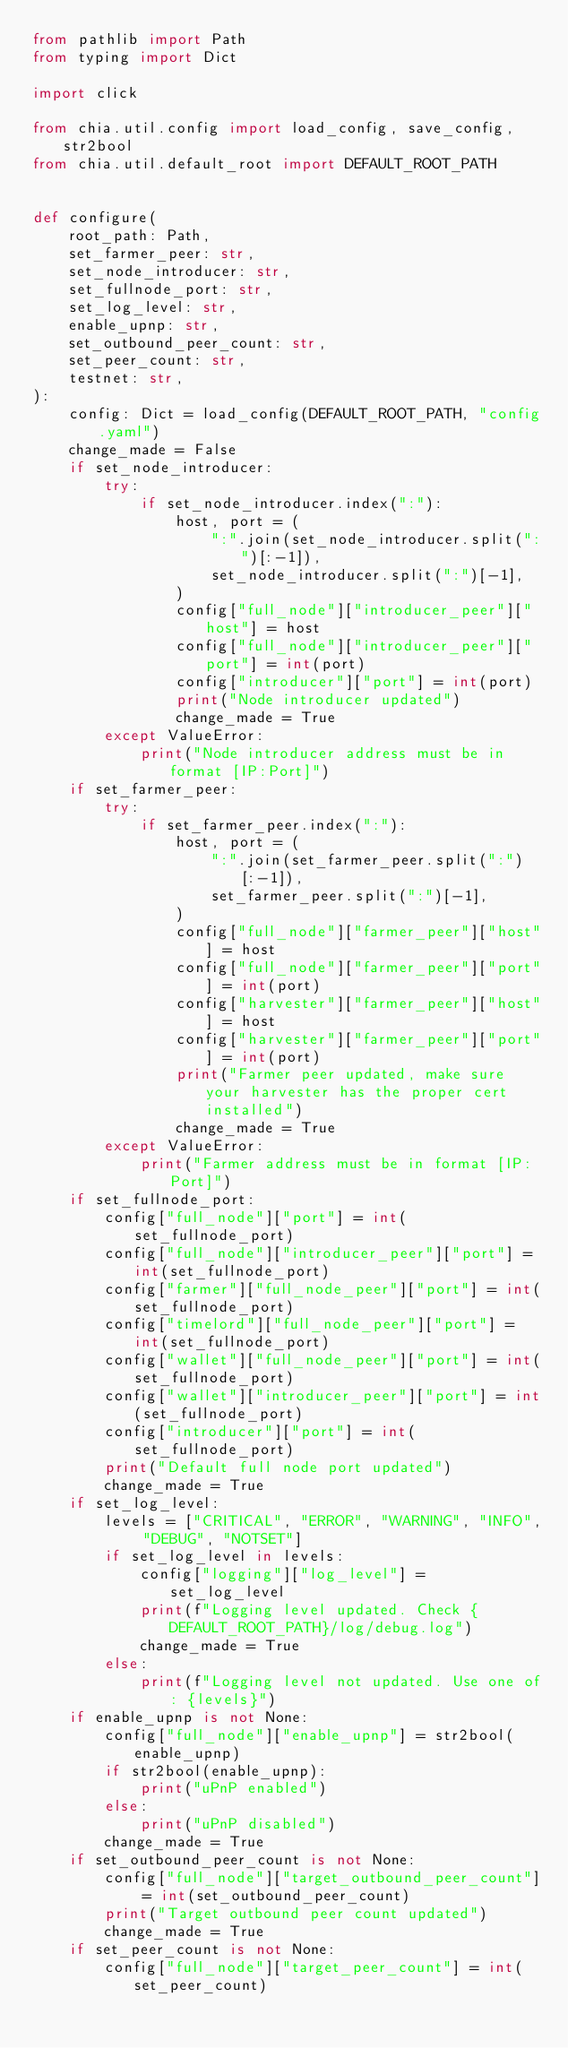<code> <loc_0><loc_0><loc_500><loc_500><_Python_>from pathlib import Path
from typing import Dict

import click

from chia.util.config import load_config, save_config, str2bool
from chia.util.default_root import DEFAULT_ROOT_PATH


def configure(
    root_path: Path,
    set_farmer_peer: str,
    set_node_introducer: str,
    set_fullnode_port: str,
    set_log_level: str,
    enable_upnp: str,
    set_outbound_peer_count: str,
    set_peer_count: str,
    testnet: str,
):
    config: Dict = load_config(DEFAULT_ROOT_PATH, "config.yaml")
    change_made = False
    if set_node_introducer:
        try:
            if set_node_introducer.index(":"):
                host, port = (
                    ":".join(set_node_introducer.split(":")[:-1]),
                    set_node_introducer.split(":")[-1],
                )
                config["full_node"]["introducer_peer"]["host"] = host
                config["full_node"]["introducer_peer"]["port"] = int(port)
                config["introducer"]["port"] = int(port)
                print("Node introducer updated")
                change_made = True
        except ValueError:
            print("Node introducer address must be in format [IP:Port]")
    if set_farmer_peer:
        try:
            if set_farmer_peer.index(":"):
                host, port = (
                    ":".join(set_farmer_peer.split(":")[:-1]),
                    set_farmer_peer.split(":")[-1],
                )
                config["full_node"]["farmer_peer"]["host"] = host
                config["full_node"]["farmer_peer"]["port"] = int(port)
                config["harvester"]["farmer_peer"]["host"] = host
                config["harvester"]["farmer_peer"]["port"] = int(port)
                print("Farmer peer updated, make sure your harvester has the proper cert installed")
                change_made = True
        except ValueError:
            print("Farmer address must be in format [IP:Port]")
    if set_fullnode_port:
        config["full_node"]["port"] = int(set_fullnode_port)
        config["full_node"]["introducer_peer"]["port"] = int(set_fullnode_port)
        config["farmer"]["full_node_peer"]["port"] = int(set_fullnode_port)
        config["timelord"]["full_node_peer"]["port"] = int(set_fullnode_port)
        config["wallet"]["full_node_peer"]["port"] = int(set_fullnode_port)
        config["wallet"]["introducer_peer"]["port"] = int(set_fullnode_port)
        config["introducer"]["port"] = int(set_fullnode_port)
        print("Default full node port updated")
        change_made = True
    if set_log_level:
        levels = ["CRITICAL", "ERROR", "WARNING", "INFO", "DEBUG", "NOTSET"]
        if set_log_level in levels:
            config["logging"]["log_level"] = set_log_level
            print(f"Logging level updated. Check {DEFAULT_ROOT_PATH}/log/debug.log")
            change_made = True
        else:
            print(f"Logging level not updated. Use one of: {levels}")
    if enable_upnp is not None:
        config["full_node"]["enable_upnp"] = str2bool(enable_upnp)
        if str2bool(enable_upnp):
            print("uPnP enabled")
        else:
            print("uPnP disabled")
        change_made = True
    if set_outbound_peer_count is not None:
        config["full_node"]["target_outbound_peer_count"] = int(set_outbound_peer_count)
        print("Target outbound peer count updated")
        change_made = True
    if set_peer_count is not None:
        config["full_node"]["target_peer_count"] = int(set_peer_count)</code> 